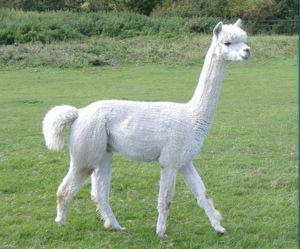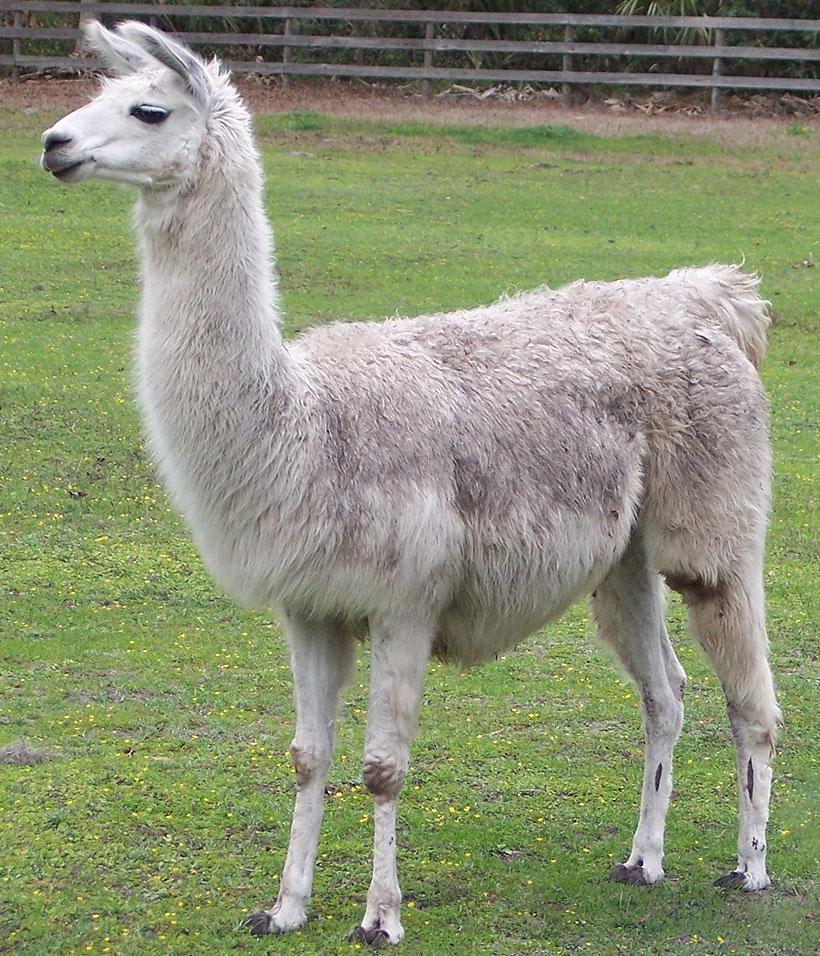The first image is the image on the left, the second image is the image on the right. For the images displayed, is the sentence "The left and right image contains the same number of Llamas facing the same direction." factually correct? Answer yes or no. No. The first image is the image on the left, the second image is the image on the right. For the images shown, is this caption "Each image contains a single llama, no llama looks straight at the camera, and the llamas on the left and right share similar fur coloring and body poses." true? Answer yes or no. Yes. 